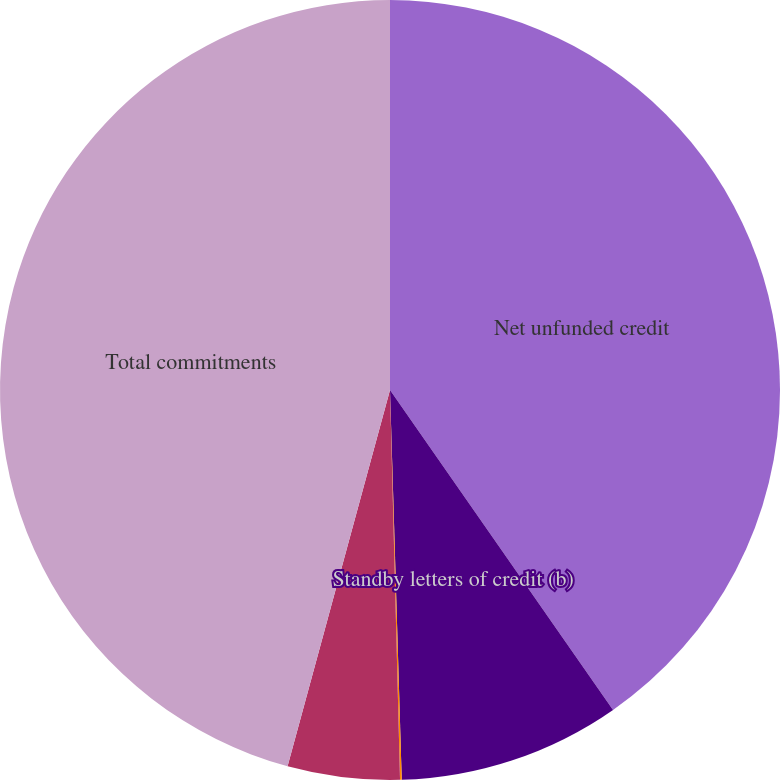Convert chart to OTSL. <chart><loc_0><loc_0><loc_500><loc_500><pie_chart><fcel>Net unfunded credit<fcel>Standby letters of credit (b)<fcel>Reinsurance agreements (c)<fcel>Other commitments (d)<fcel>Total commitments<nl><fcel>40.31%<fcel>9.21%<fcel>0.07%<fcel>4.64%<fcel>45.77%<nl></chart> 